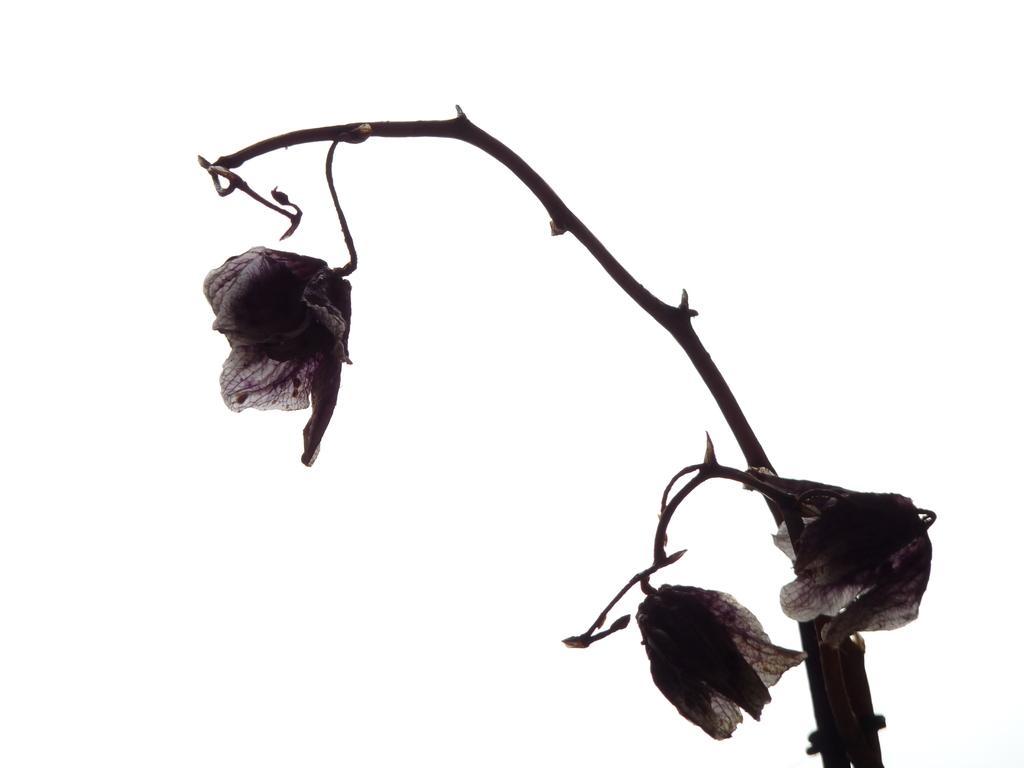Could you give a brief overview of what you see in this image? In this image there is a stem. There are thorns and dried flowers to the stem. The background is white. 